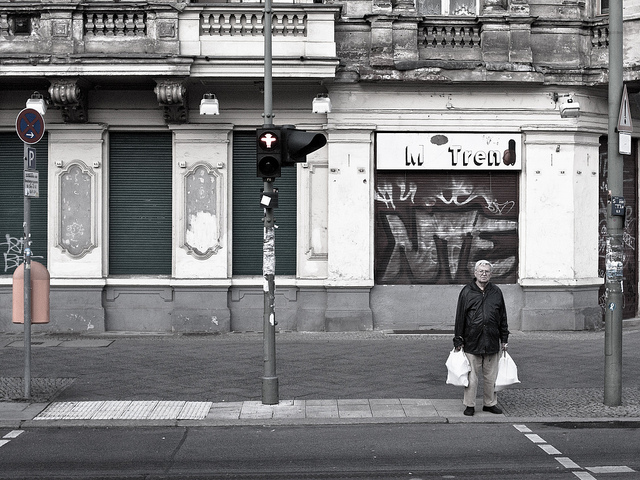Please identify all text content in this image. M Trend NTE P 